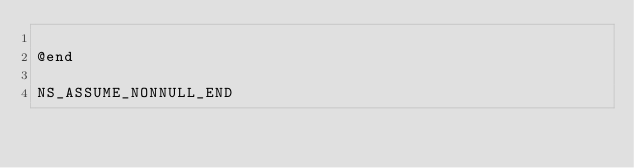Convert code to text. <code><loc_0><loc_0><loc_500><loc_500><_C_>
@end

NS_ASSUME_NONNULL_END
</code> 